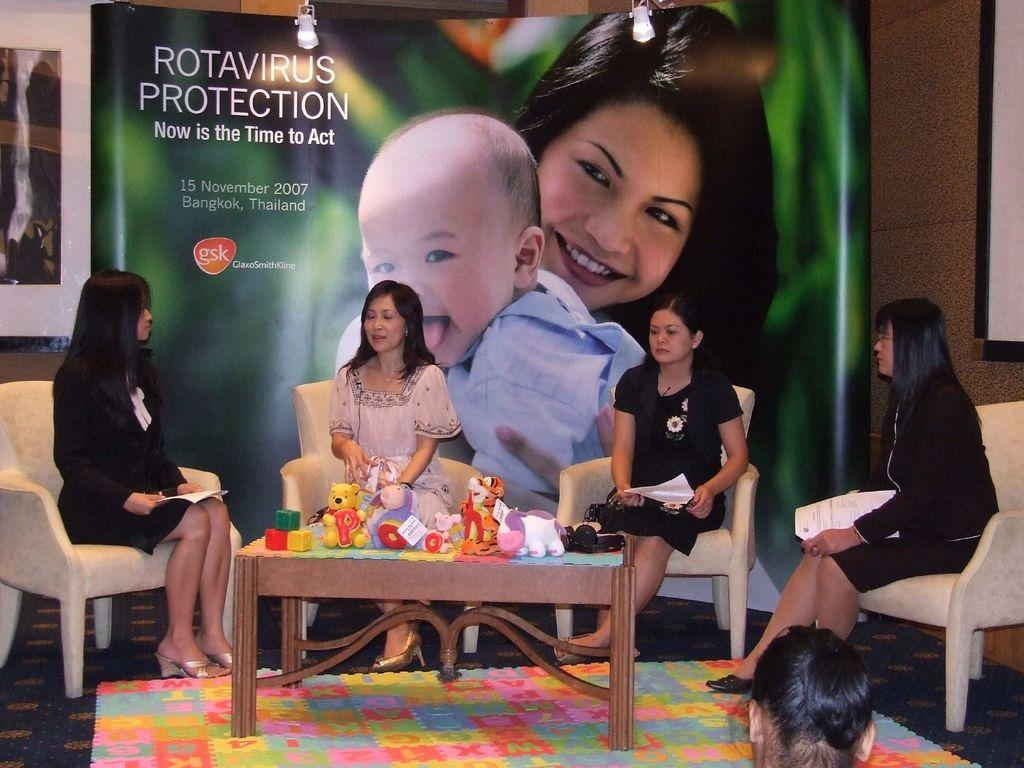How many people are seated in the image? There are four people seated on chairs in the image. What is the main piece of furniture in the image? There is a table in the image. What can be found on the table? Toys are present on the table. What is depicted on the poster in the background? There is a poster of a woman and a baby on the back. What type of board game are the people playing in the image? There is no board game present in the image. How many boys are visible in the image? The provided facts do not mention the gender of the people in the image, so it cannot be determined if there are any boys present. 